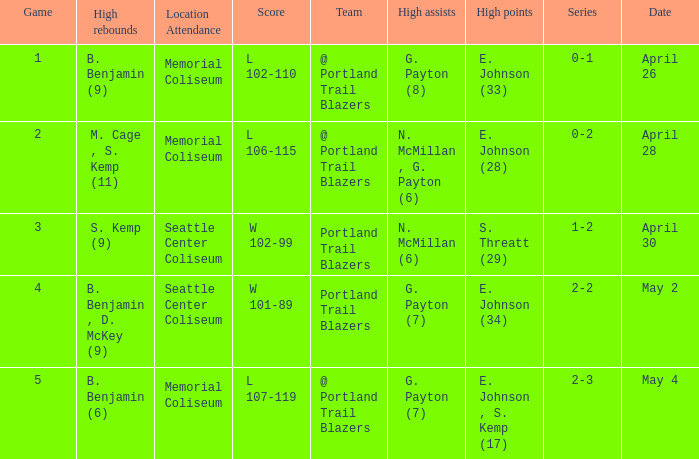With a 0-2 series, what is the high points? E. Johnson (28). 